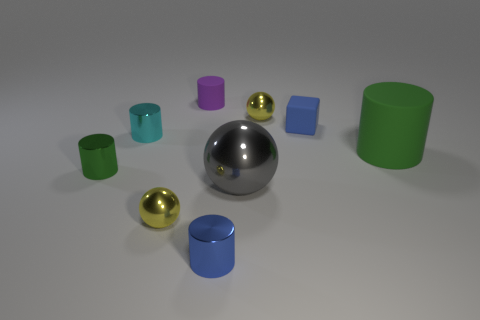Subtract all yellow spheres. How many spheres are left? 1 Subtract 1 balls. How many balls are left? 2 Subtract all purple cylinders. How many cylinders are left? 4 Add 1 matte objects. How many objects exist? 10 Subtract all yellow cylinders. Subtract all green balls. How many cylinders are left? 5 Subtract all spheres. How many objects are left? 6 Add 2 yellow metal balls. How many yellow metal balls exist? 4 Subtract 0 brown cubes. How many objects are left? 9 Subtract all blue cubes. Subtract all green shiny objects. How many objects are left? 7 Add 6 small metallic balls. How many small metallic balls are left? 8 